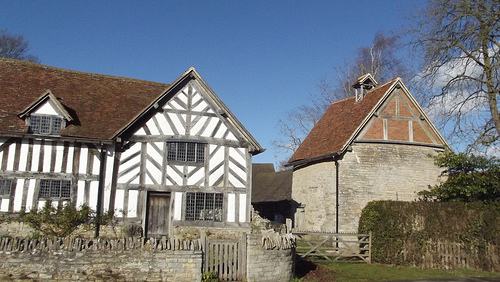<image>
Is the window to the left of the door? No. The window is not to the left of the door. From this viewpoint, they have a different horizontal relationship. 